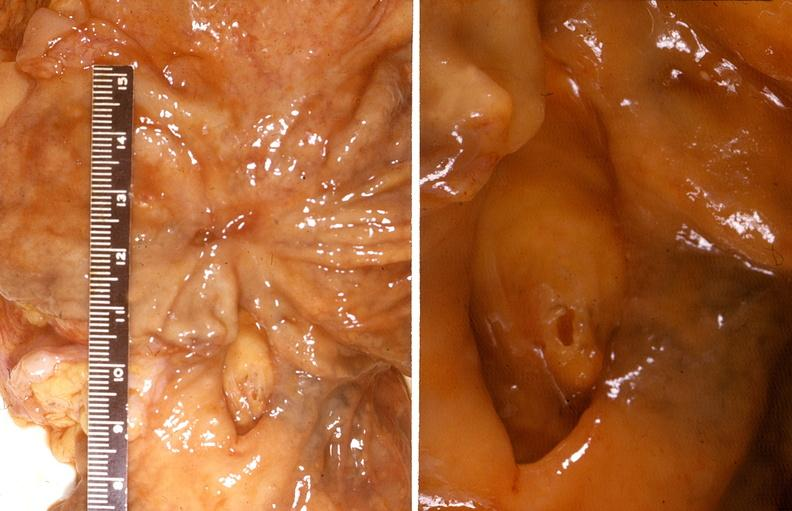what does this image show?
Answer the question using a single word or phrase. Stomach 